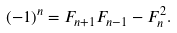Convert formula to latex. <formula><loc_0><loc_0><loc_500><loc_500>( - 1 ) ^ { n } = F _ { n + 1 } F _ { n - 1 } - F _ { n } ^ { 2 } .</formula> 